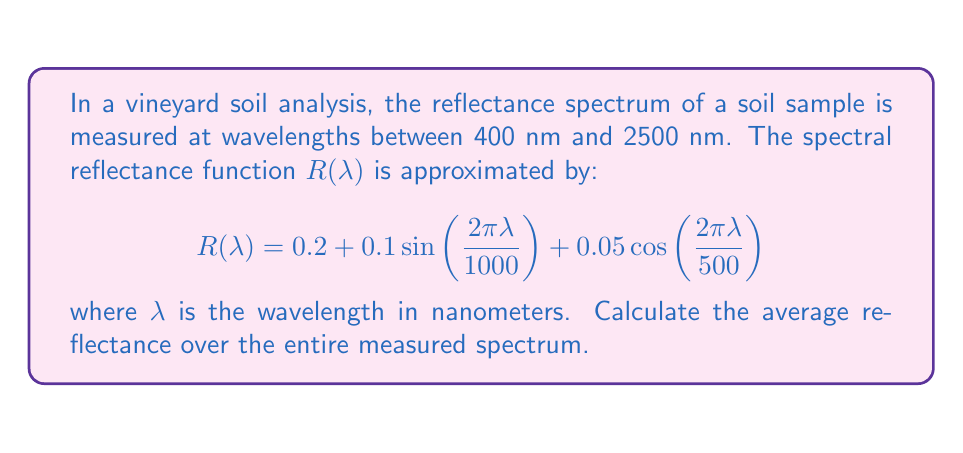Teach me how to tackle this problem. To find the average reflectance, we need to integrate the reflectance function over the given wavelength range and divide by the total range. The steps are as follows:

1) The average reflectance is given by:

   $$\bar{R} = \frac{1}{2500 - 400} \int_{400}^{2500} R(\lambda) d\lambda$$

2) Substitute the given function:

   $$\bar{R} = \frac{1}{2100} \int_{400}^{2500} \left[0.2 + 0.1\sin\left(\frac{2\pi\lambda}{1000}\right) + 0.05\cos\left(\frac{2\pi\lambda}{500}\right)\right] d\lambda$$

3) Integrate each term separately:

   a) $\int 0.2 d\lambda = 0.2\lambda$
   
   b) $\int 0.1\sin\left(\frac{2\pi\lambda}{1000}\right) d\lambda = -\frac{100}{2\pi}\cos\left(\frac{2\pi\lambda}{1000}\right)$
   
   c) $\int 0.05\cos\left(\frac{2\pi\lambda}{500}\right) d\lambda = \frac{25}{2\pi}\sin\left(\frac{2\pi\lambda}{500}\right)$

4) Apply the limits:

   $$\bar{R} = \frac{1}{2100}\left[0.2\lambda - \frac{100}{2\pi}\cos\left(\frac{2\pi\lambda}{1000}\right) + \frac{25}{2\pi}\sin\left(\frac{2\pi\lambda}{500}\right)\right]_{400}^{2500}$$

5) Evaluate:

   $$\bar{R} = \frac{1}{2100}\left[(0.2 \cdot 2500 - 0.2 \cdot 400) + \frac{100}{2\pi}(\cos(5\pi) - \cos(4\pi/5)) + \frac{25}{2\pi}(\sin(10\pi) - \sin(8\pi/5))\right]$$

6) Simplify:

   $$\bar{R} = \frac{1}{2100}\left[420 + \frac{100}{2\pi}(-1 + 0.309) + \frac{25}{2\pi}(0 - 0.951)\right] = 0.2 - 0.00034 - 0.00009 = 0.19957$$
Answer: 0.19957 